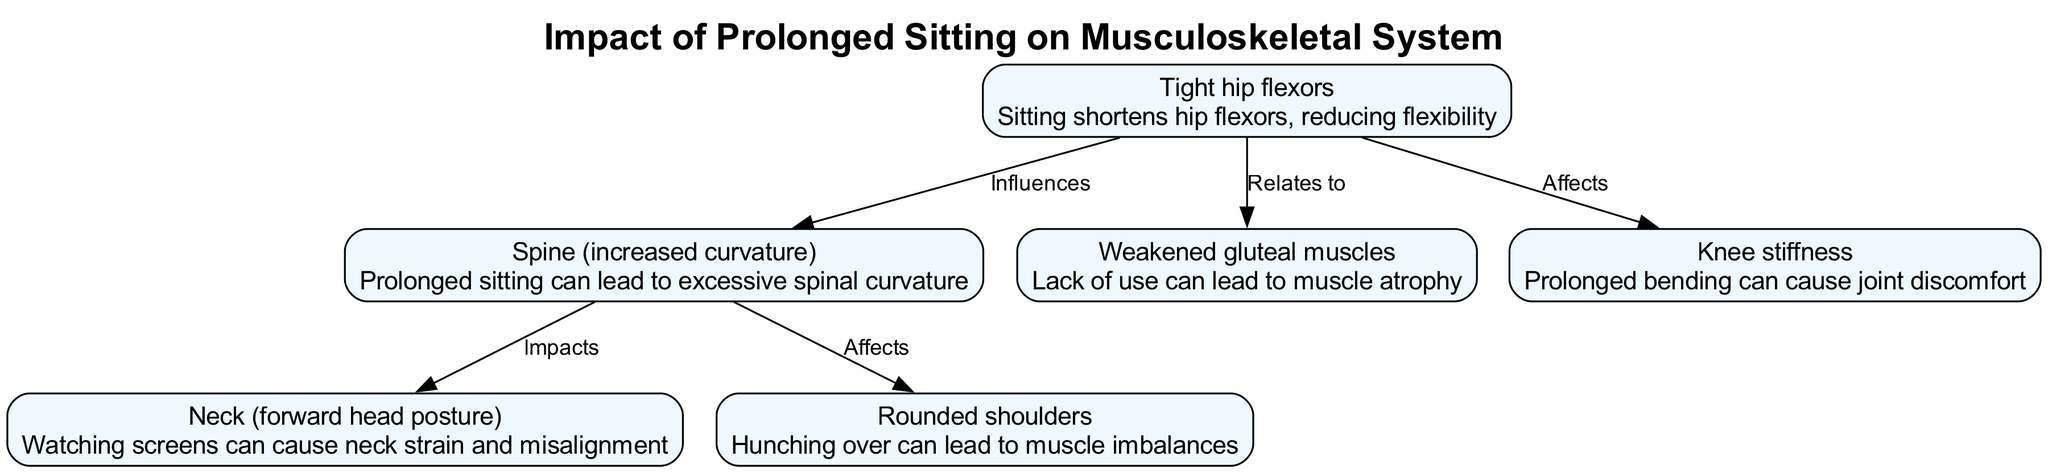What is the label of the first node? The first node in the diagram is labeled "Spine (increased curvature)". The nodes are listed in the order they are added, and the first one corresponds to the spinal condition resulting from prolonged sitting.
Answer: Spine (increased curvature) How many edges are there in total? Counting the connections between nodes indicates there are a total of five edges. Each edge represents a relationship between nodes, and the totals are simply summed from the data provided.
Answer: 5 What body part is impacted by the "Spine"? The diagram shows that the "Spine" impacts both the "Neck" and "Shoulders" as indicated by the relationships depicted. The nature of these connections describes how issues with spinal curvature can affect these areas.
Answer: Neck, Shoulders Which node is related to both the "Hips" and "Knees"? The "Hips" node directly relates to the "Knees" through an edge labeled “Affects,” meaning that tightness in hip flexors can impact knee stiffness. This relationship illustrates a common issue experienced by those who sit for long periods.
Answer: Knees What type of muscle condition is linked to the lack of use of gluteal muscles? The condition linked to a lack of use of gluteal muscles is "muscle atrophy." This term directly refers to the weakening of these muscles due to prolonged sitting, highlighting a key issue for retired individuals.
Answer: Muscle atrophy Which node describes forward head posture? The node describing forward head posture is labeled "Neck (forward head posture)". This indicates the association between screen time while sitting and neck alignment problems.
Answer: Neck (forward head posture) Explain the relationship between "Hips" and "Glutes". The "Hips" influence the "Glutes" as depicted in the diagram. "Tight hip flexors" can lead to weakened gluteal muscles, associating reduced flexibility in the hips with atrophy in the glutes. This indicates the broader implications of prolonged sitting on muscle conditions.
Answer: Weakened gluteal muscles Which node describes a condition resulting from prolonged bending? The node that describes a condition resulting from prolonged bending is "Knee stiffness." This condition is a direct consequence of maintaining a bent position for extended periods when sitting.
Answer: Knee stiffness 